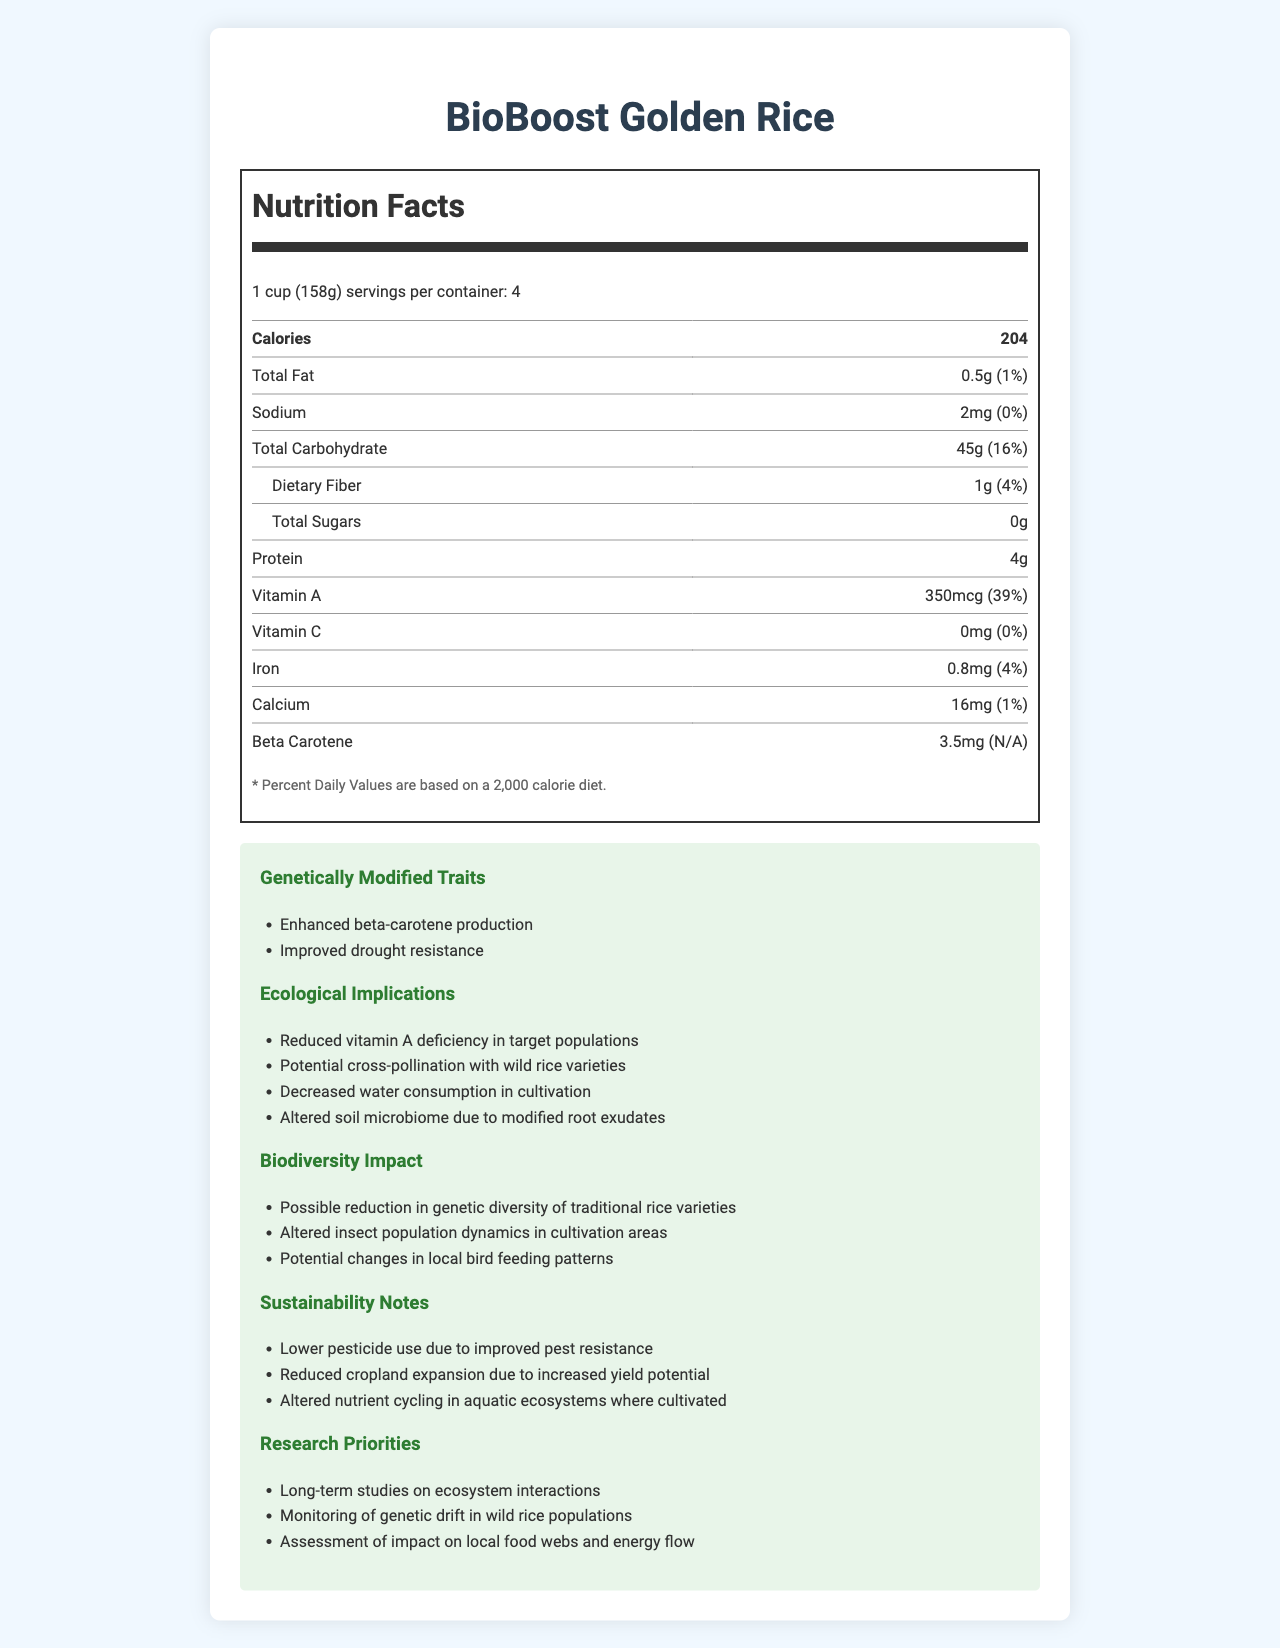who produces BioBoost Golden Rice? The document does not provide information about the producer of BioBoost Golden Rice.
Answer: Not mentioned what is the serving size of BioBoost Golden Rice? The document specifies that the serving size is 1 cup, which is equivalent to 158 grams.
Answer: 1 cup (158g) how many servings are there per container? The document states that there are 4 servings per container.
Answer: 4 what is the amount of calories per serving? The nutrition facts indicate that each serving contains 204 calories.
Answer: 204 what percentage of the daily value of Vitamin A does BioBoost Golden Rice provide? The document shows that the Vitamin A content per serving is 350mcg, which is 39% of the daily value.
Answer: 39% identify one genetically modified trait of the BioBoost Golden Rice The document lists "Enhanced beta-carotene production" as one of the genetically modified traits.
Answer: Enhanced beta-carotene production which of the following is an ecological implication mentioned in the document?
i. Reduced vitamin A deficiency in target populations
ii. Increased use of pesticides
iii. Improved soil quality The document states "Reduced vitamin A deficiency in target populations" as an ecological implication.
Answer: i. Reduced vitamin A deficiency in target populations how much Beta Carotene is present in BioBoost Golden Rice? According to the document, BioBoost Golden Rice contains 3.5mg of Beta Carotene per serving.
Answer: 3.5mg what is one potential biodiversity impact of cultivating BioBoost Golden Rice? The document lists "Possible reduction in genetic diversity of traditional rice varieties" as a biodiversity impact.
Answer: Possible reduction in genetic diversity of traditional rice varieties true or false: BioBoost Golden Rice contains 10mg of Iron per serving The document states that BioBoost Golden Rice contains 0.8mg of Iron per serving, not 10mg.
Answer: False what is the amount of protein in one serving of BioBoost Golden Rice? The nutrition label indicates that there are 4 grams of protein per serving.
Answer: 4g what are the reported amounts of Vitamin C and Calcium in BioBoost Golden Rice? The document states that Vitamin C is 0mg and Calcium is 16mg per serving.
Answer: Vitamin C: 0mg, Calcium: 16mg which of the following is a sustainability note associated with BioBoost Golden Rice?
A. Increased use of chemical fertilizers
B. Lower pesticide use due to improved pest resistance
C. Increased need for water resources The document mentions "Lower pesticide use due to improved pest resistance" as a sustainability note.
Answer: B. Lower pesticide use due to improved pest resistance how does BioBoost Golden Rice potentially affect local bird feeding patterns? The document indicates "Potential changes in local bird feeding patterns" as a biodiversity impact.
Answer: Potential changes in local bird feeding patterns is BioBoost Golden Rice higher in dietary fiber or total sugars? The document shows that BioBoost Golden Rice contains 1g of dietary fiber and 0g of total sugars, making it higher in dietary fiber.
Answer: Dietary fiber summarize the main ecological implications of BioBoost Golden Rice as listed in the document The document elaborates on various ecological implications such as the positive health impact on vitamin A deficiency, concerns regarding cross-pollination with wild rice, the benefit of decreased water consumption in cultivation, and the potential changes in the soil microbiome due to modified root exudates.
Answer: The main ecological implications include reduced vitamin A deficiency, potential cross-pollination with wild rice, decreased water consumption in cultivation, and altered soil microbiome. what are the iron and sodium daily values provided by one serving of BioBoost Golden Rice? The document states that one serving of BioBoost Golden Rice provides 4% of the daily value for iron and 0% for sodium.
Answer: Iron: 4%, Sodium: 0% how many calories would a person consume if they ate the entire container of BioBoost Golden Rice? Since there are 204 calories per serving and 4 servings per container, the total calories would be 204 * 4 = 816.
Answer: 816 which of the following research priorities are listed in the document? (Select all that apply)
1. Long-term studies on ecosystem interactions
2. Development of new pesticide formulations
3. Monitoring of genetic drift in wild rice populations
4. Assessment of impact on local food webs and energy flow The document lists "Long-term studies on ecosystem interactions," "Monitoring of genetic drift in wild rice populations," and "Assessment of impact on local food webs and energy flow" as research priorities.
Answer: 1, 3, 4 